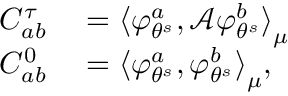Convert formula to latex. <formula><loc_0><loc_0><loc_500><loc_500>\begin{array} { r l } { C _ { a b } ^ { \tau } } & = { \langle \varphi _ { \theta ^ { s } } ^ { a } , \mathcal { A } \varphi _ { \theta ^ { s } } ^ { b } \rangle } _ { \mu } } \\ { C _ { a b } ^ { 0 } } & = { \langle \varphi _ { \theta ^ { s } } ^ { a } , \varphi _ { \theta ^ { s } } ^ { b } \rangle } _ { \mu } , } \end{array}</formula> 